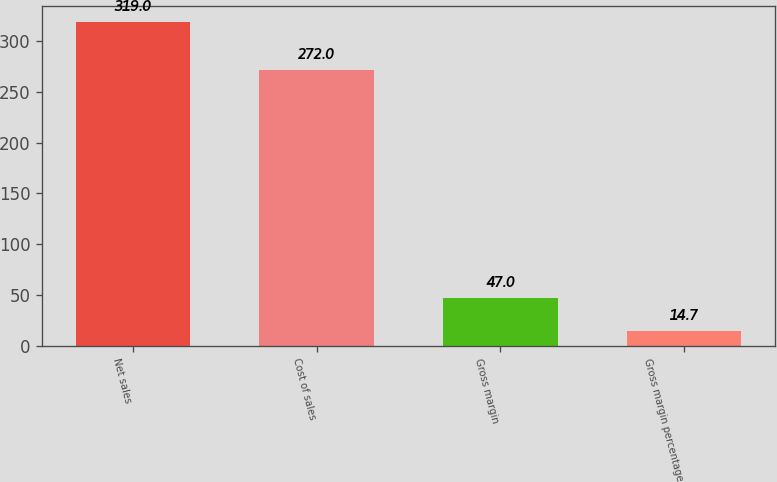<chart> <loc_0><loc_0><loc_500><loc_500><bar_chart><fcel>Net sales<fcel>Cost of sales<fcel>Gross margin<fcel>Gross margin percentage<nl><fcel>319<fcel>272<fcel>47<fcel>14.7<nl></chart> 